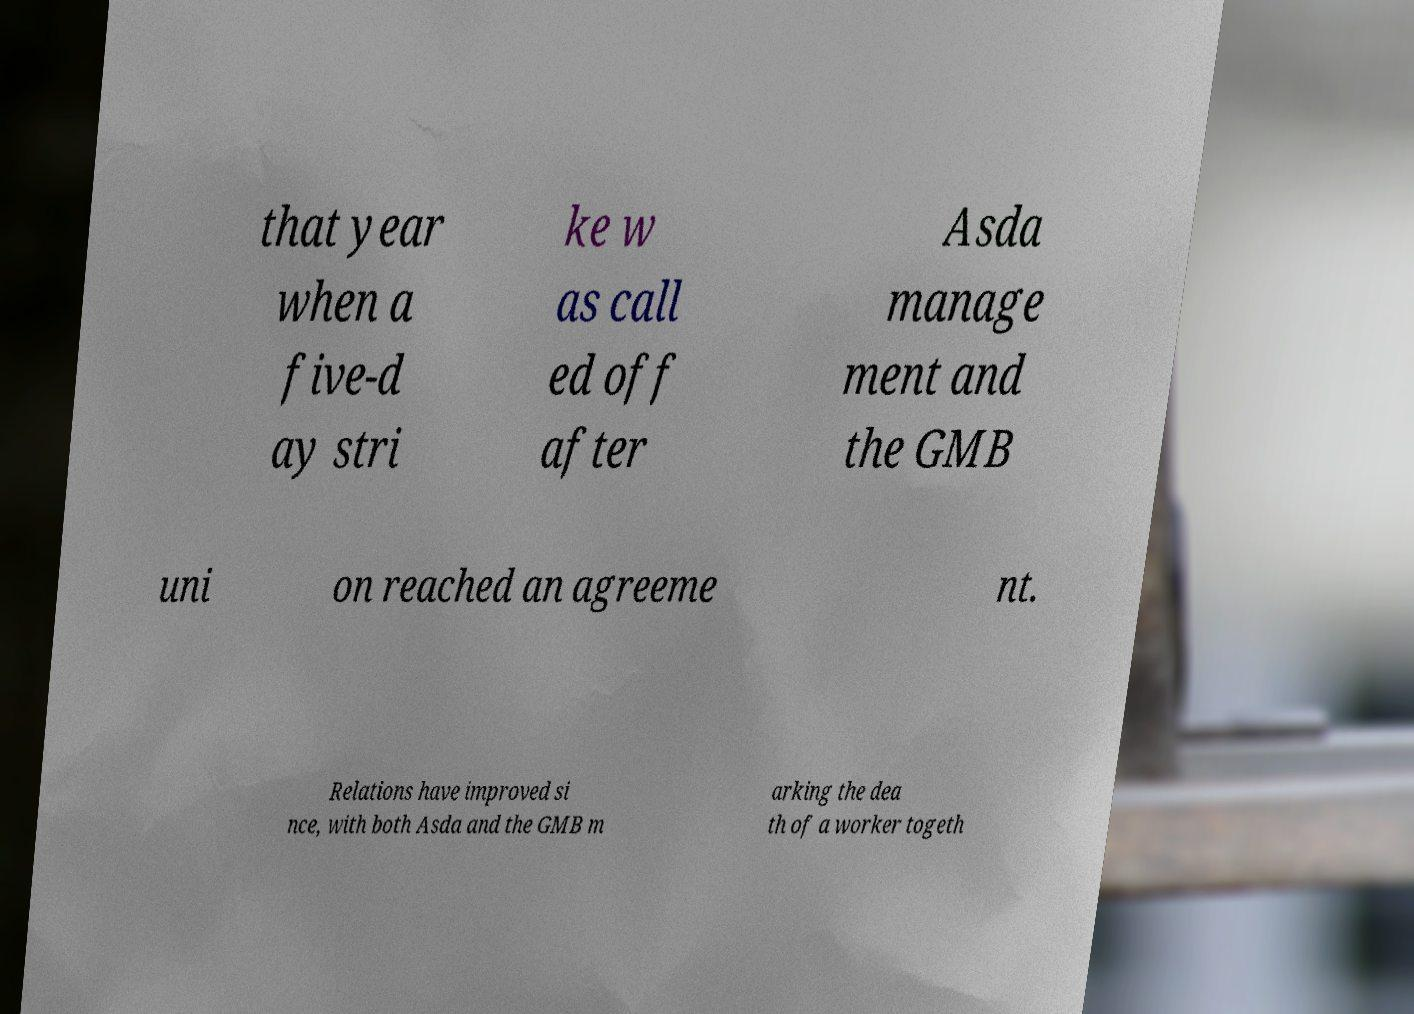Please identify and transcribe the text found in this image. that year when a five-d ay stri ke w as call ed off after Asda manage ment and the GMB uni on reached an agreeme nt. Relations have improved si nce, with both Asda and the GMB m arking the dea th of a worker togeth 